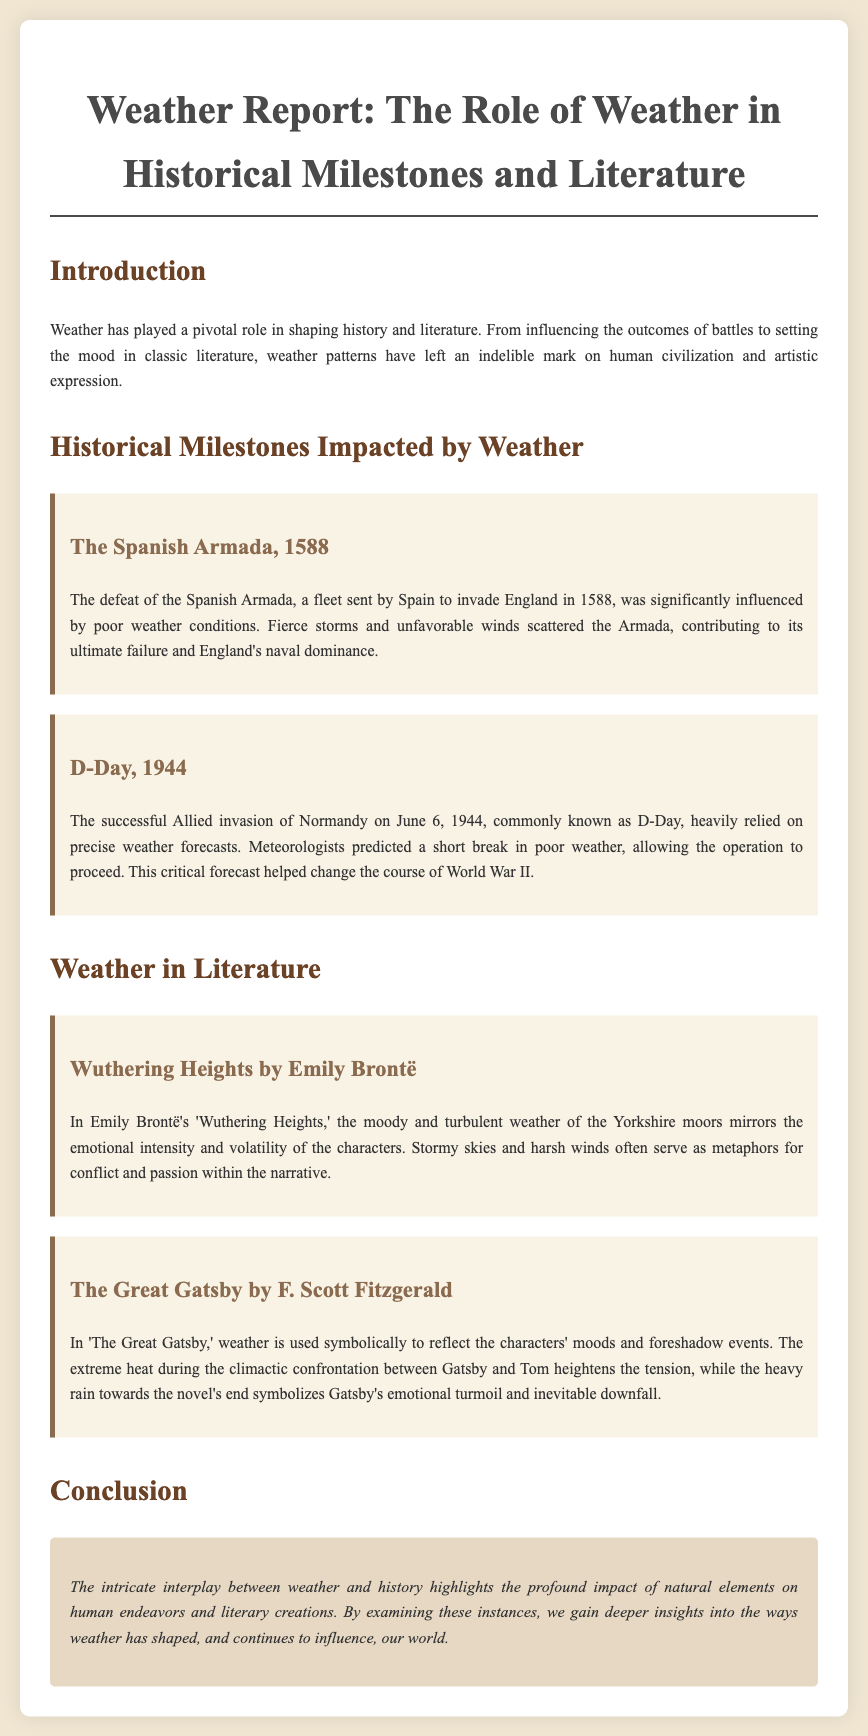What year did the Spanish Armada occur? The document mentions that the Spanish Armada occurred in 1588.
Answer: 1588 What was a significant weather condition during D-Day? The document indicates that precise weather forecasts were crucial, specifically a short break in poor weather.
Answer: short break in poor weather Which novel features the Yorkshire moors? The document states that "Wuthering Heights" by Emily Brontë features the Yorkshire moors.
Answer: Wuthering Heights What symbolizes Gatsby's emotional turmoil in "The Great Gatsby"? The document explains that heavy rain towards the novel's end symbolizes Gatsby's emotional turmoil.
Answer: heavy rain What was the outcome of the Spanish Armada's encounter with weather? The document states that fierce storms and unfavorable winds contributed to the Armada's ultimate failure.
Answer: ultimate failure How did weather influence the invasion on June 6, 1944? The document explains that the operation relied on precise weather forecasts that predicted a break in bad weather.
Answer: relied on precise weather forecasts What literary technique is used in "Wuthering Heights"? The document mentions that stormy skies and harsh winds serve as metaphors for conflict and passion.
Answer: metaphors What was the primary effect of weather on the D-Day invasion? The document notes that favorable weather conditions allowed the operation to proceed, changing the course of World War II.
Answer: changing the course of World War II 